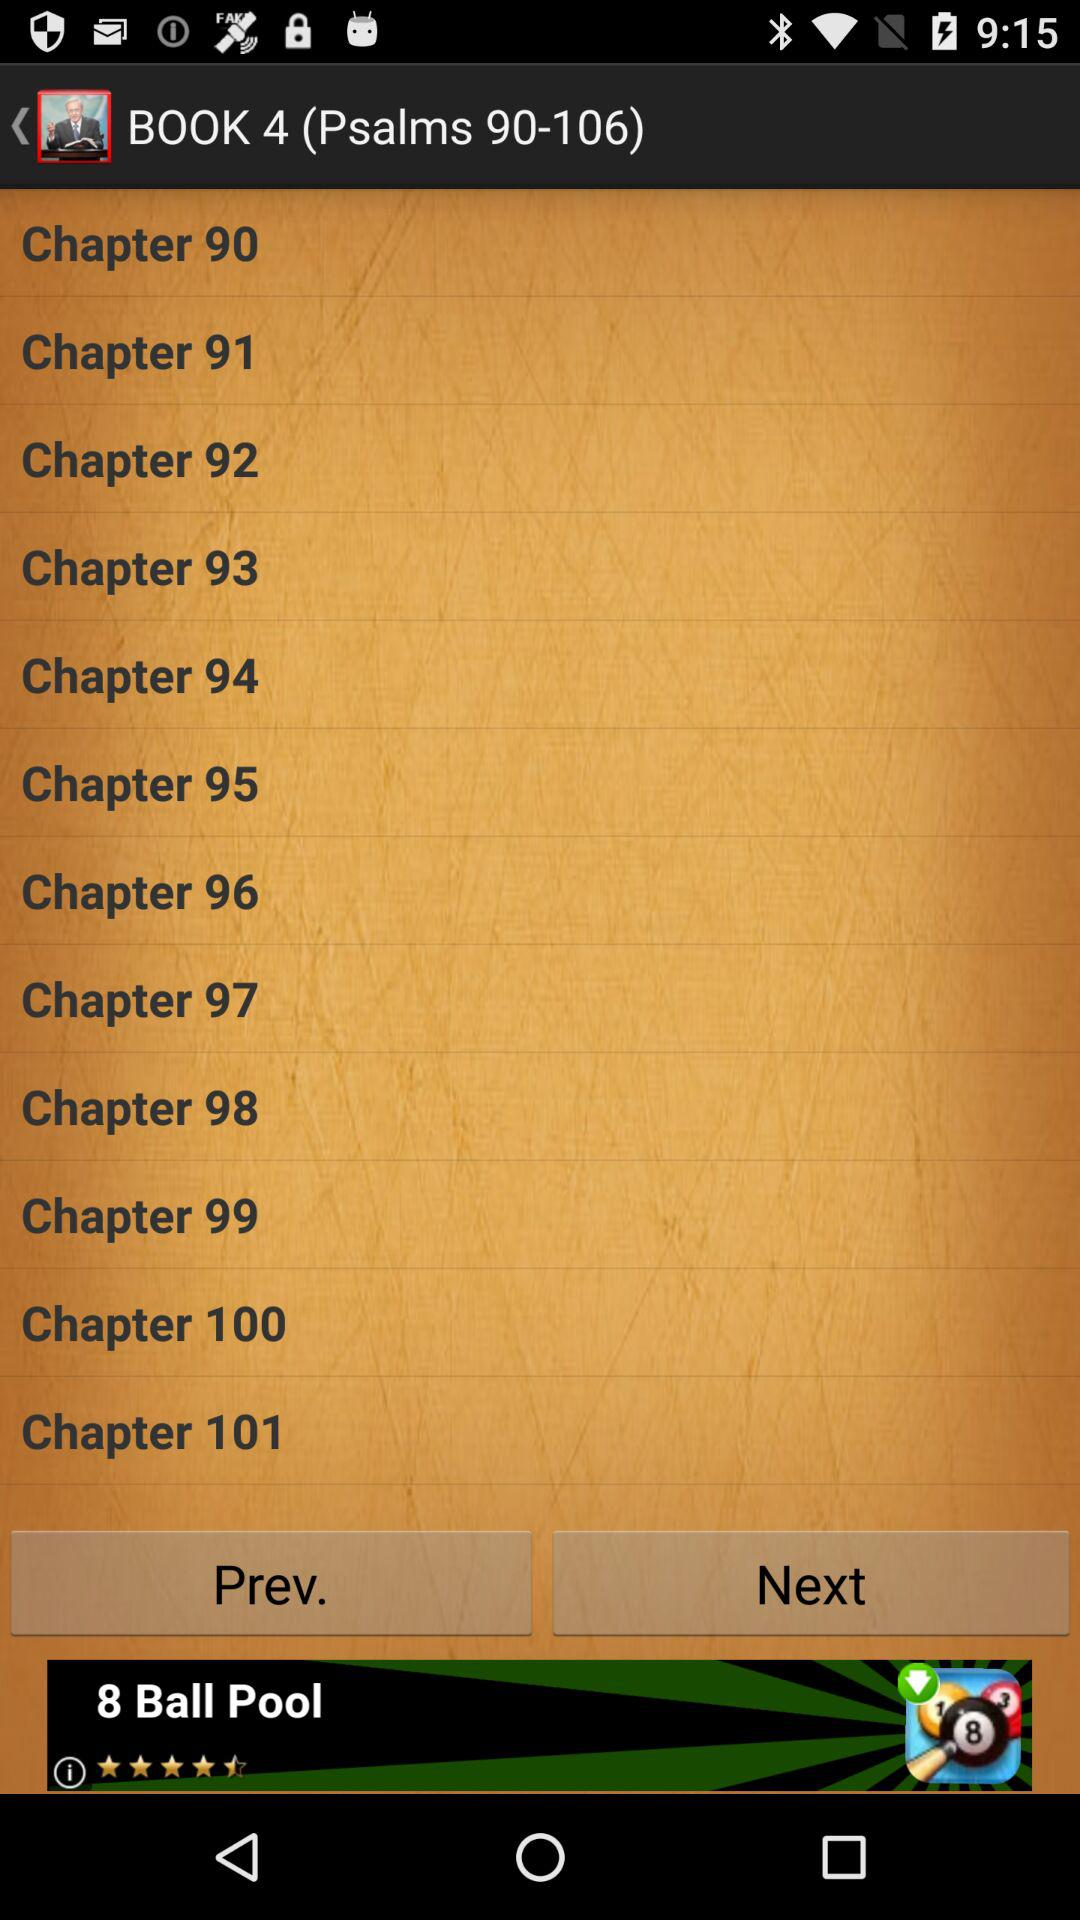Which book contains "Psalms 1-41"? "Psalms 1-41" are in book 1. 